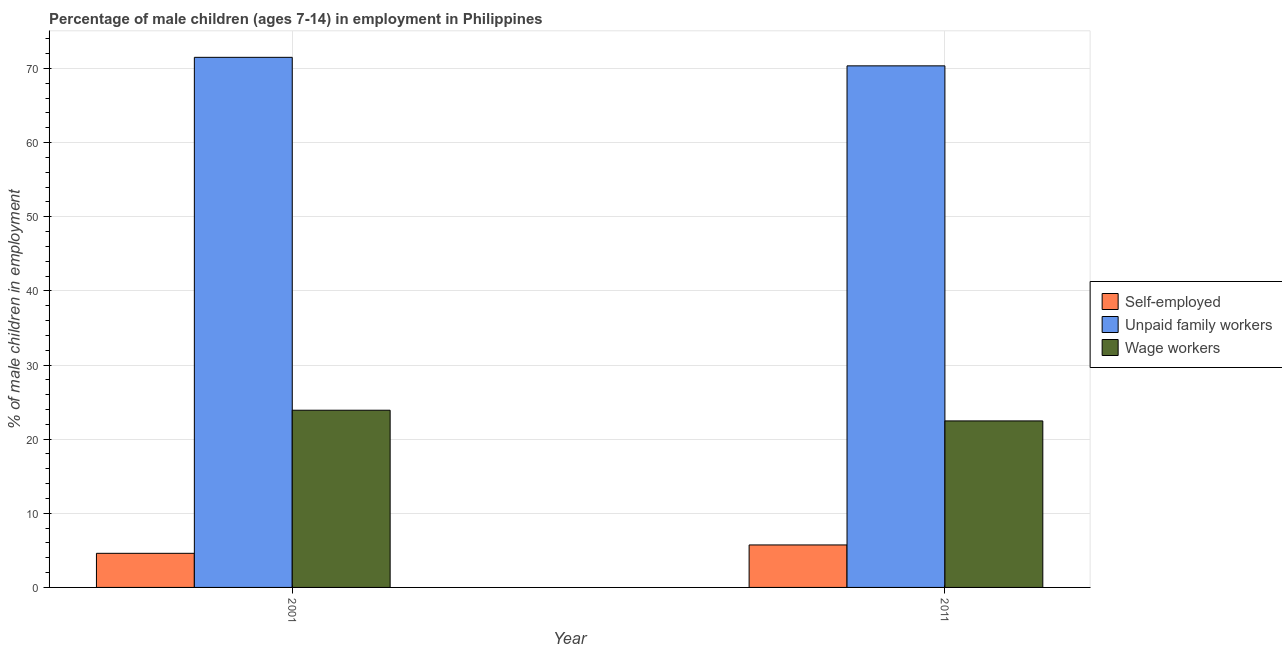How many different coloured bars are there?
Your answer should be very brief. 3. Are the number of bars per tick equal to the number of legend labels?
Offer a terse response. Yes. Are the number of bars on each tick of the X-axis equal?
Offer a very short reply. Yes. How many bars are there on the 2nd tick from the right?
Offer a terse response. 3. What is the percentage of children employed as wage workers in 2011?
Keep it short and to the point. 22.46. Across all years, what is the maximum percentage of children employed as unpaid family workers?
Provide a succinct answer. 71.5. Across all years, what is the minimum percentage of self employed children?
Keep it short and to the point. 4.6. What is the total percentage of children employed as wage workers in the graph?
Your response must be concise. 46.36. What is the difference between the percentage of self employed children in 2001 and that in 2011?
Offer a terse response. -1.13. What is the difference between the percentage of children employed as wage workers in 2011 and the percentage of self employed children in 2001?
Offer a very short reply. -1.44. What is the average percentage of children employed as wage workers per year?
Offer a very short reply. 23.18. In the year 2011, what is the difference between the percentage of children employed as wage workers and percentage of self employed children?
Keep it short and to the point. 0. In how many years, is the percentage of children employed as wage workers greater than 4 %?
Provide a short and direct response. 2. What is the ratio of the percentage of self employed children in 2001 to that in 2011?
Keep it short and to the point. 0.8. Is the percentage of children employed as unpaid family workers in 2001 less than that in 2011?
Your answer should be compact. No. In how many years, is the percentage of self employed children greater than the average percentage of self employed children taken over all years?
Provide a short and direct response. 1. What does the 3rd bar from the left in 2011 represents?
Provide a short and direct response. Wage workers. What does the 2nd bar from the right in 2001 represents?
Provide a short and direct response. Unpaid family workers. How many bars are there?
Give a very brief answer. 6. What is the difference between two consecutive major ticks on the Y-axis?
Offer a very short reply. 10. Does the graph contain any zero values?
Keep it short and to the point. No. Does the graph contain grids?
Offer a very short reply. Yes. What is the title of the graph?
Offer a very short reply. Percentage of male children (ages 7-14) in employment in Philippines. Does "Other sectors" appear as one of the legend labels in the graph?
Provide a short and direct response. No. What is the label or title of the Y-axis?
Your answer should be very brief. % of male children in employment. What is the % of male children in employment in Self-employed in 2001?
Offer a very short reply. 4.6. What is the % of male children in employment of Unpaid family workers in 2001?
Offer a terse response. 71.5. What is the % of male children in employment in Wage workers in 2001?
Make the answer very short. 23.9. What is the % of male children in employment in Self-employed in 2011?
Your answer should be very brief. 5.73. What is the % of male children in employment in Unpaid family workers in 2011?
Your answer should be compact. 70.35. What is the % of male children in employment in Wage workers in 2011?
Your response must be concise. 22.46. Across all years, what is the maximum % of male children in employment in Self-employed?
Provide a succinct answer. 5.73. Across all years, what is the maximum % of male children in employment in Unpaid family workers?
Offer a very short reply. 71.5. Across all years, what is the maximum % of male children in employment in Wage workers?
Your answer should be very brief. 23.9. Across all years, what is the minimum % of male children in employment of Unpaid family workers?
Your answer should be very brief. 70.35. Across all years, what is the minimum % of male children in employment in Wage workers?
Ensure brevity in your answer.  22.46. What is the total % of male children in employment in Self-employed in the graph?
Keep it short and to the point. 10.33. What is the total % of male children in employment of Unpaid family workers in the graph?
Make the answer very short. 141.85. What is the total % of male children in employment of Wage workers in the graph?
Keep it short and to the point. 46.36. What is the difference between the % of male children in employment in Self-employed in 2001 and that in 2011?
Give a very brief answer. -1.13. What is the difference between the % of male children in employment in Unpaid family workers in 2001 and that in 2011?
Offer a very short reply. 1.15. What is the difference between the % of male children in employment in Wage workers in 2001 and that in 2011?
Your answer should be very brief. 1.44. What is the difference between the % of male children in employment of Self-employed in 2001 and the % of male children in employment of Unpaid family workers in 2011?
Offer a terse response. -65.75. What is the difference between the % of male children in employment in Self-employed in 2001 and the % of male children in employment in Wage workers in 2011?
Offer a very short reply. -17.86. What is the difference between the % of male children in employment in Unpaid family workers in 2001 and the % of male children in employment in Wage workers in 2011?
Your answer should be very brief. 49.04. What is the average % of male children in employment of Self-employed per year?
Make the answer very short. 5.17. What is the average % of male children in employment in Unpaid family workers per year?
Make the answer very short. 70.92. What is the average % of male children in employment in Wage workers per year?
Ensure brevity in your answer.  23.18. In the year 2001, what is the difference between the % of male children in employment of Self-employed and % of male children in employment of Unpaid family workers?
Offer a terse response. -66.9. In the year 2001, what is the difference between the % of male children in employment in Self-employed and % of male children in employment in Wage workers?
Provide a short and direct response. -19.3. In the year 2001, what is the difference between the % of male children in employment of Unpaid family workers and % of male children in employment of Wage workers?
Offer a terse response. 47.6. In the year 2011, what is the difference between the % of male children in employment of Self-employed and % of male children in employment of Unpaid family workers?
Ensure brevity in your answer.  -64.62. In the year 2011, what is the difference between the % of male children in employment in Self-employed and % of male children in employment in Wage workers?
Your answer should be very brief. -16.73. In the year 2011, what is the difference between the % of male children in employment of Unpaid family workers and % of male children in employment of Wage workers?
Offer a terse response. 47.89. What is the ratio of the % of male children in employment of Self-employed in 2001 to that in 2011?
Your answer should be compact. 0.8. What is the ratio of the % of male children in employment in Unpaid family workers in 2001 to that in 2011?
Make the answer very short. 1.02. What is the ratio of the % of male children in employment of Wage workers in 2001 to that in 2011?
Give a very brief answer. 1.06. What is the difference between the highest and the second highest % of male children in employment in Self-employed?
Provide a short and direct response. 1.13. What is the difference between the highest and the second highest % of male children in employment of Unpaid family workers?
Offer a terse response. 1.15. What is the difference between the highest and the second highest % of male children in employment in Wage workers?
Your answer should be very brief. 1.44. What is the difference between the highest and the lowest % of male children in employment in Self-employed?
Provide a short and direct response. 1.13. What is the difference between the highest and the lowest % of male children in employment of Unpaid family workers?
Keep it short and to the point. 1.15. What is the difference between the highest and the lowest % of male children in employment in Wage workers?
Provide a short and direct response. 1.44. 